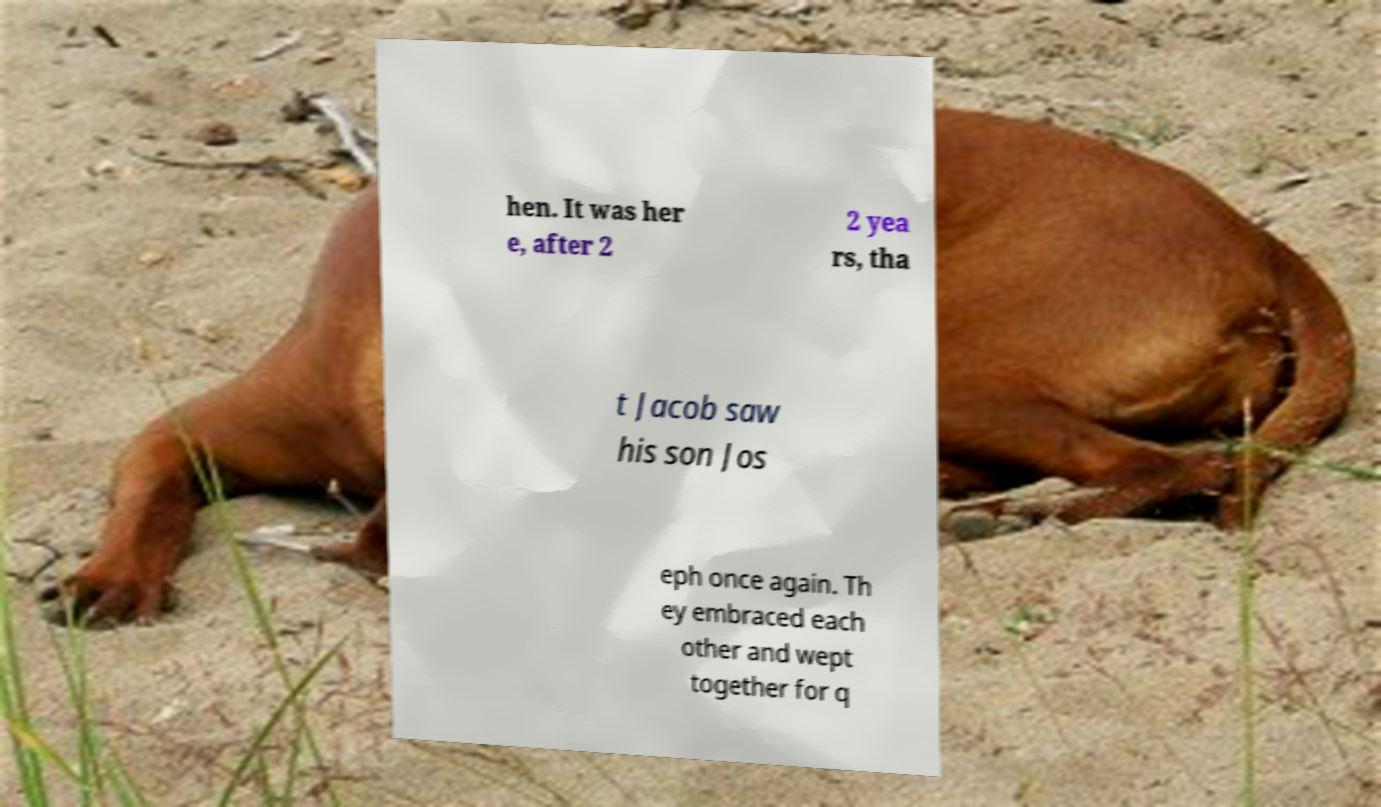Could you assist in decoding the text presented in this image and type it out clearly? hen. It was her e, after 2 2 yea rs, tha t Jacob saw his son Jos eph once again. Th ey embraced each other and wept together for q 